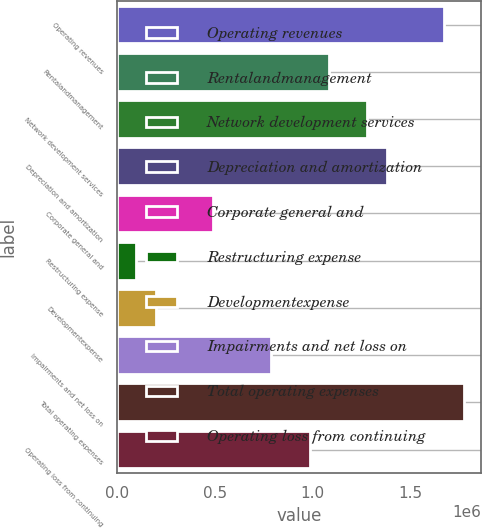<chart> <loc_0><loc_0><loc_500><loc_500><bar_chart><fcel>Operating revenues<fcel>Rentalandmanagement<fcel>Network development services<fcel>Depreciation and amortization<fcel>Corporate general and<fcel>Restructuring expense<fcel>Developmentexpense<fcel>Impairments and net loss on<fcel>Total operating expenses<fcel>Operating loss from continuing<nl><fcel>1.67364e+06<fcel>1.08306e+06<fcel>1.27992e+06<fcel>1.37835e+06<fcel>492472<fcel>98748.8<fcel>197180<fcel>787764<fcel>1.77207e+06<fcel>984626<nl></chart> 